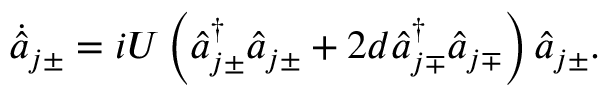Convert formula to latex. <formula><loc_0><loc_0><loc_500><loc_500>\begin{array} { r } { \dot { \hat { a } } _ { j \pm } = i U \left ( \hat { a } _ { j \pm } ^ { \dagger } \hat { a } _ { j \pm } + 2 d \hat { a } _ { j \mp } ^ { \dagger } \hat { a } _ { j \mp } \right ) \hat { a } _ { j \pm } . } \end{array}</formula> 